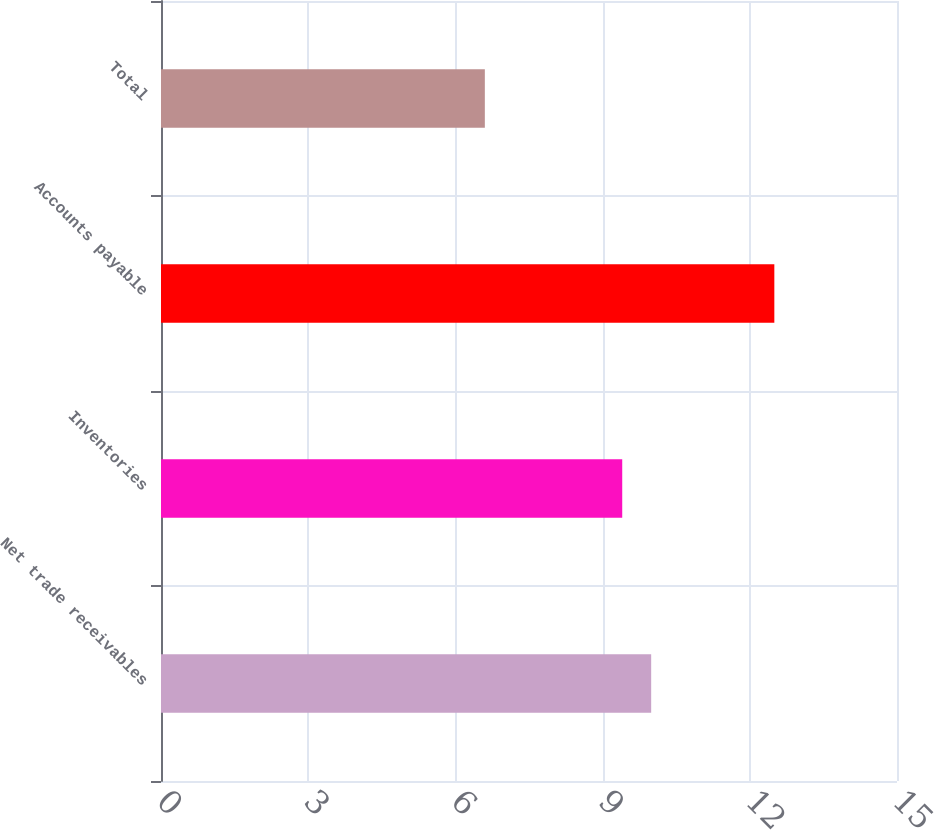Convert chart. <chart><loc_0><loc_0><loc_500><loc_500><bar_chart><fcel>Net trade receivables<fcel>Inventories<fcel>Accounts payable<fcel>Total<nl><fcel>9.99<fcel>9.4<fcel>12.5<fcel>6.6<nl></chart> 